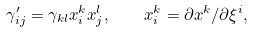<formula> <loc_0><loc_0><loc_500><loc_500>\gamma _ { i j } ^ { \prime } = \gamma _ { k l } x _ { i } ^ { k } x _ { j } ^ { l } , \quad x _ { i } ^ { k } = \partial x ^ { k } / \partial \xi ^ { i } ,</formula> 